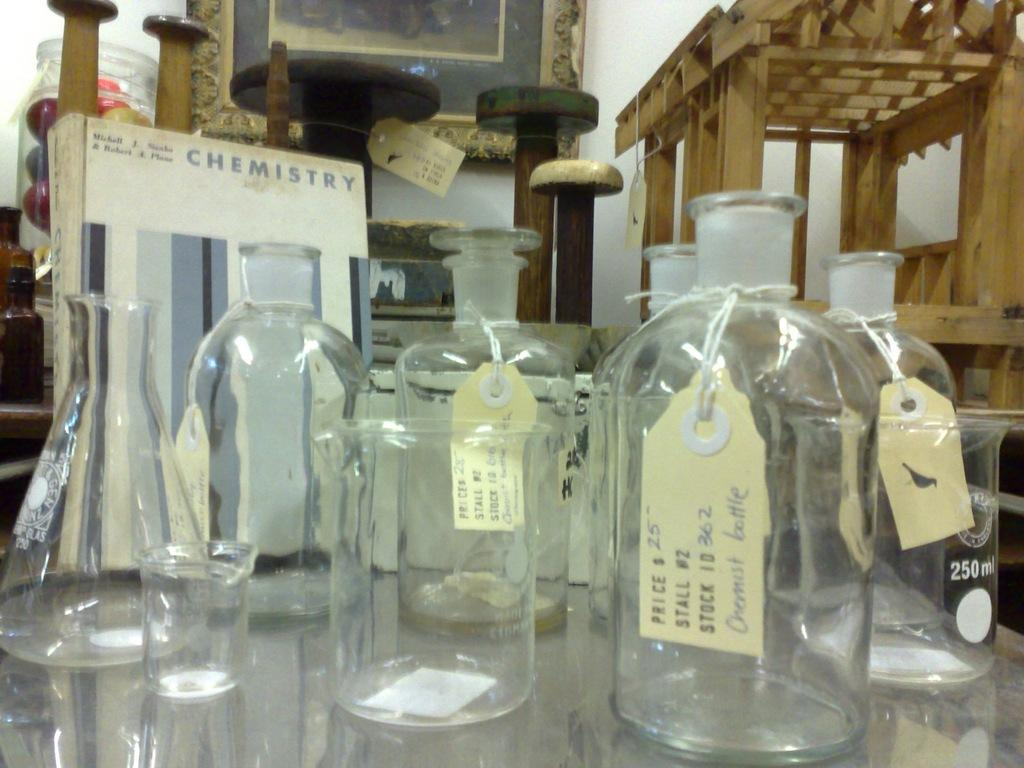<image>
Provide a brief description of the given image. Many glass bottles with tags that list their price, stall, and stock are laid out on a table. 